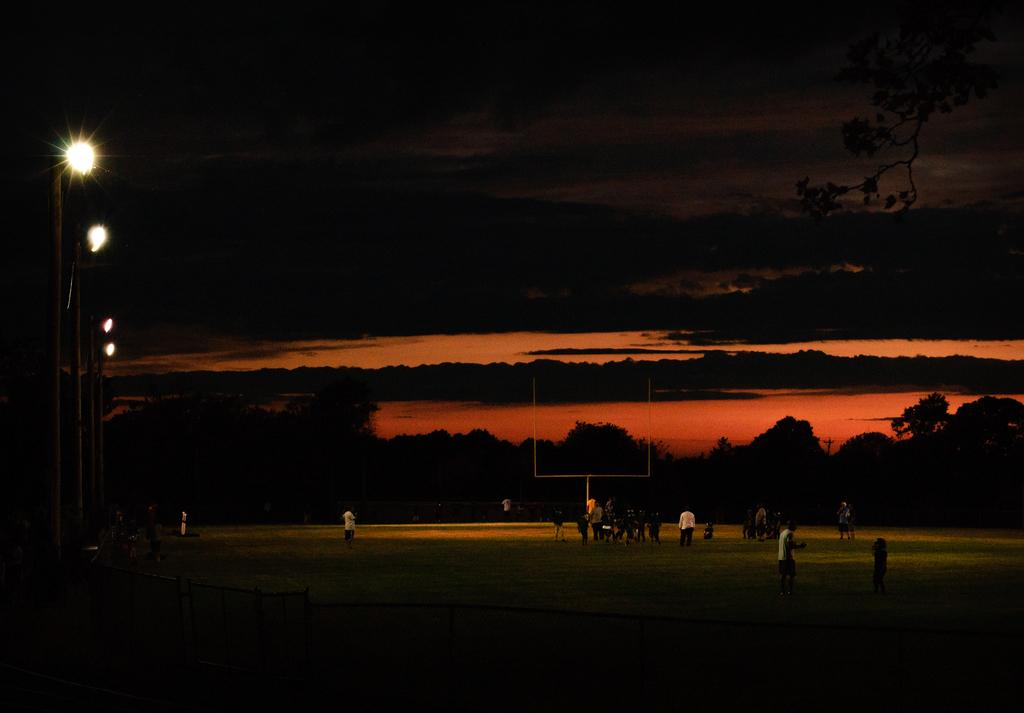What can be seen in the image? There are people, poles, lights, trees, water, and grass on the ground in the image. What is the lighting situation in the image? There are lights visible in the image. What type of natural environment is present in the image? There are trees and water visible in the image, indicating a natural environment. What is the ground covered with in the image? The ground is covered with grass in the image. How would you describe the background of the image? The background of the image is dark. What is the opinion of the snails in the image about the religious beliefs of the people? There are no snails present in the image, so it is not possible to determine their opinions about the religious beliefs of the people. 